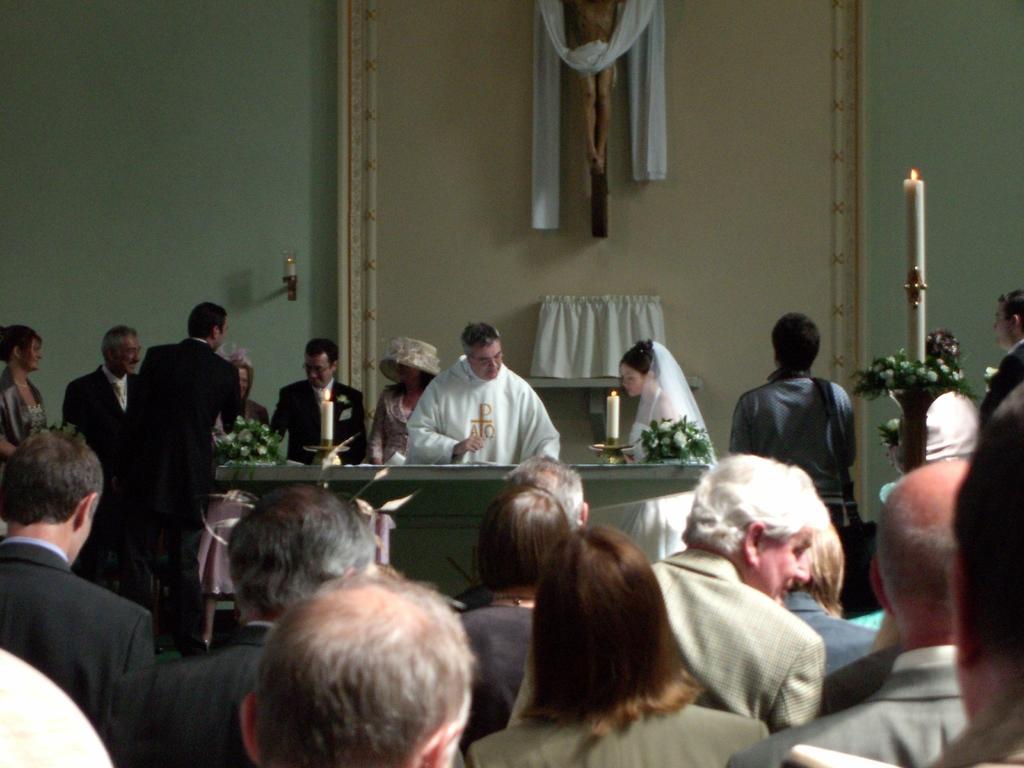Can you describe this image briefly? Here in this picture we can see a group of people standing over there and in the front we can see some other people standing and we can see a table present, on which we can see flower bouquets and candles present and we can see candles present here and there and on the wall we can see a Christianity symbol and we can see all of them are smiling. 